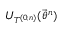Convert formula to latex. <formula><loc_0><loc_0><loc_500><loc_500>U _ { T ^ { ( 0 , n ) } } ( \vec { \theta } ^ { n } )</formula> 